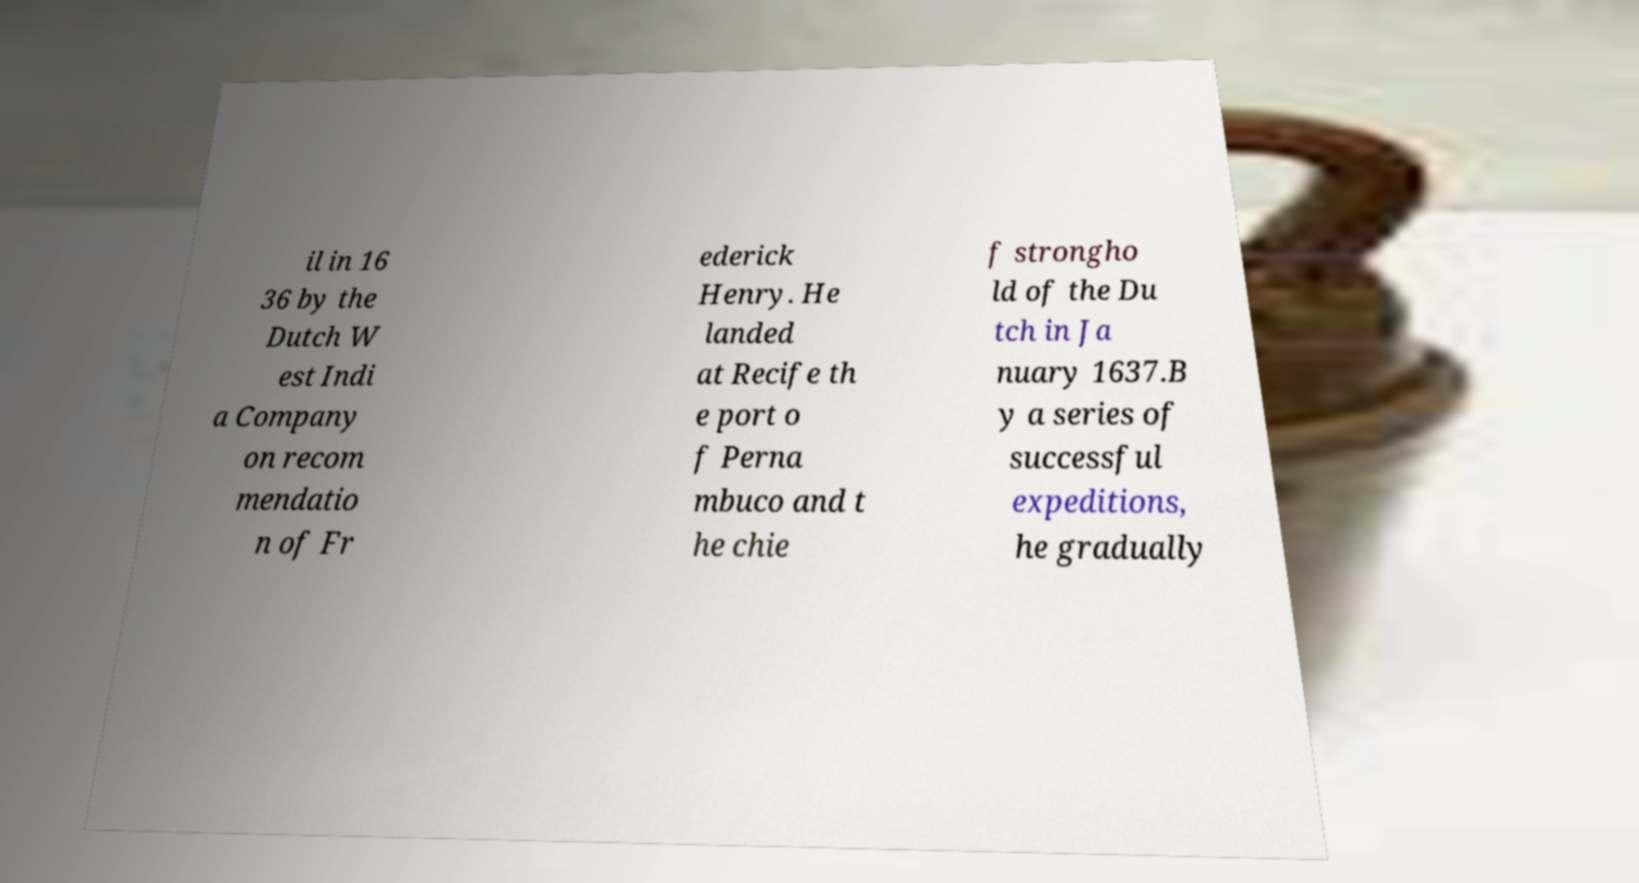Can you accurately transcribe the text from the provided image for me? il in 16 36 by the Dutch W est Indi a Company on recom mendatio n of Fr ederick Henry. He landed at Recife th e port o f Perna mbuco and t he chie f strongho ld of the Du tch in Ja nuary 1637.B y a series of successful expeditions, he gradually 